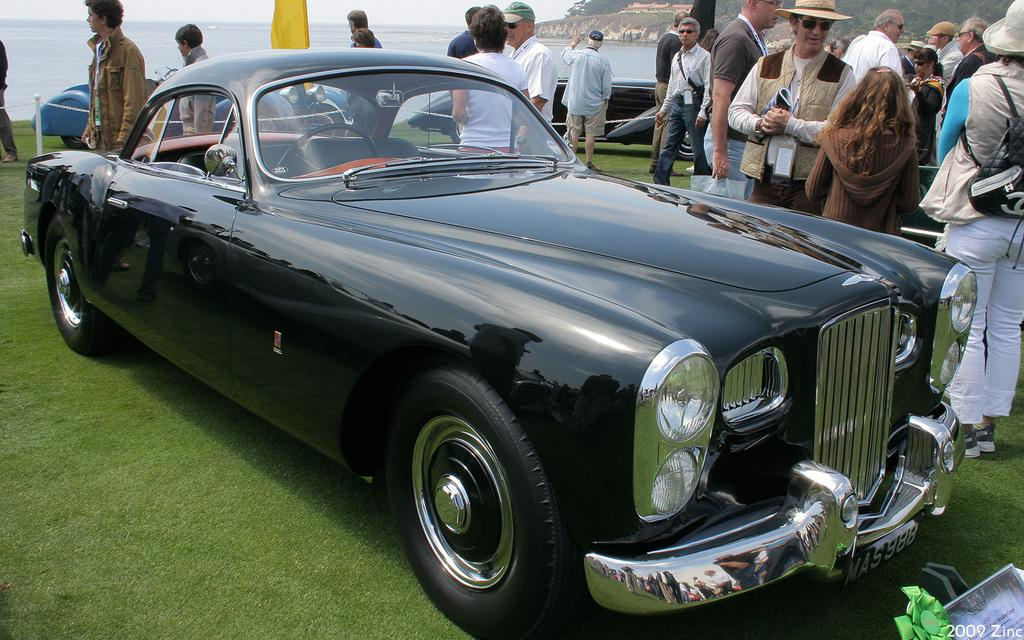What is happening in the image? There are people standing in the image. What can be found on the ground in the image? There are objects and vehicles on the ground in the image. What type of natural environment is present in the image? There are trees in the image. What is visible in the background of the image? The sky is visible in the background of the image. Is there any water visible in the image? Yes, there is water visible in the image. How many oranges are hanging from the trees in the image? There are no oranges present in the image; it features trees without any visible fruit. What type of hook can be seen attached to the vehicles in the image? There are no hooks visible on the vehicles in the image. 